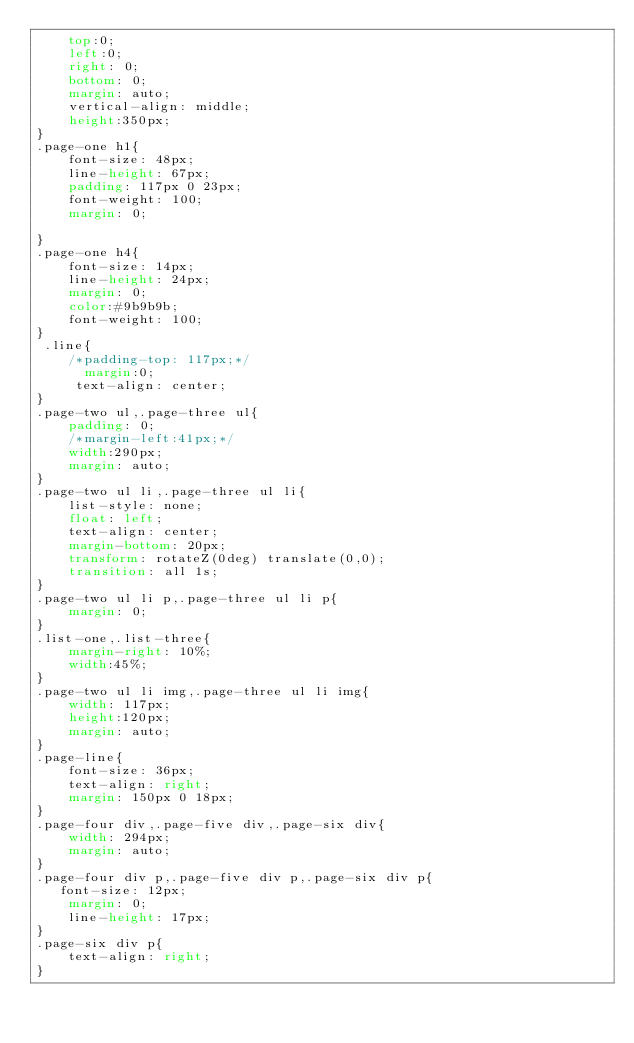Convert code to text. <code><loc_0><loc_0><loc_500><loc_500><_CSS_>    top:0;
    left:0;
    right: 0;
    bottom: 0;
    margin: auto;
    vertical-align: middle;
    height:350px;
}
.page-one h1{
    font-size: 48px;
    line-height: 67px;
    padding: 117px 0 23px;
    font-weight: 100;
    margin: 0;

}
.page-one h4{
    font-size: 14px;
    line-height: 24px;
    margin: 0;
    color:#9b9b9b;
    font-weight: 100;
}
 .line{
    /*padding-top: 117px;*/
      margin:0;
     text-align: center;
}
.page-two ul,.page-three ul{
    padding: 0;
    /*margin-left:41px;*/
    width:290px;
    margin: auto;
}
.page-two ul li,.page-three ul li{
    list-style: none;
    float: left;
    text-align: center;
    margin-bottom: 20px;
    transform: rotateZ(0deg) translate(0,0);
    transition: all 1s;
}
.page-two ul li p,.page-three ul li p{
    margin: 0;
}
.list-one,.list-three{
    margin-right: 10%;
    width:45%;
}
.page-two ul li img,.page-three ul li img{
    width: 117px;
    height:120px;
    margin: auto;
}
.page-line{
    font-size: 36px;
    text-align: right;
    margin: 150px 0 18px;
}
.page-four div,.page-five div,.page-six div{
    width: 294px;
    margin: auto;
}
.page-four div p,.page-five div p,.page-six div p{
   font-size: 12px;
    margin: 0;
    line-height: 17px;
}
.page-six div p{
    text-align: right;
}</code> 